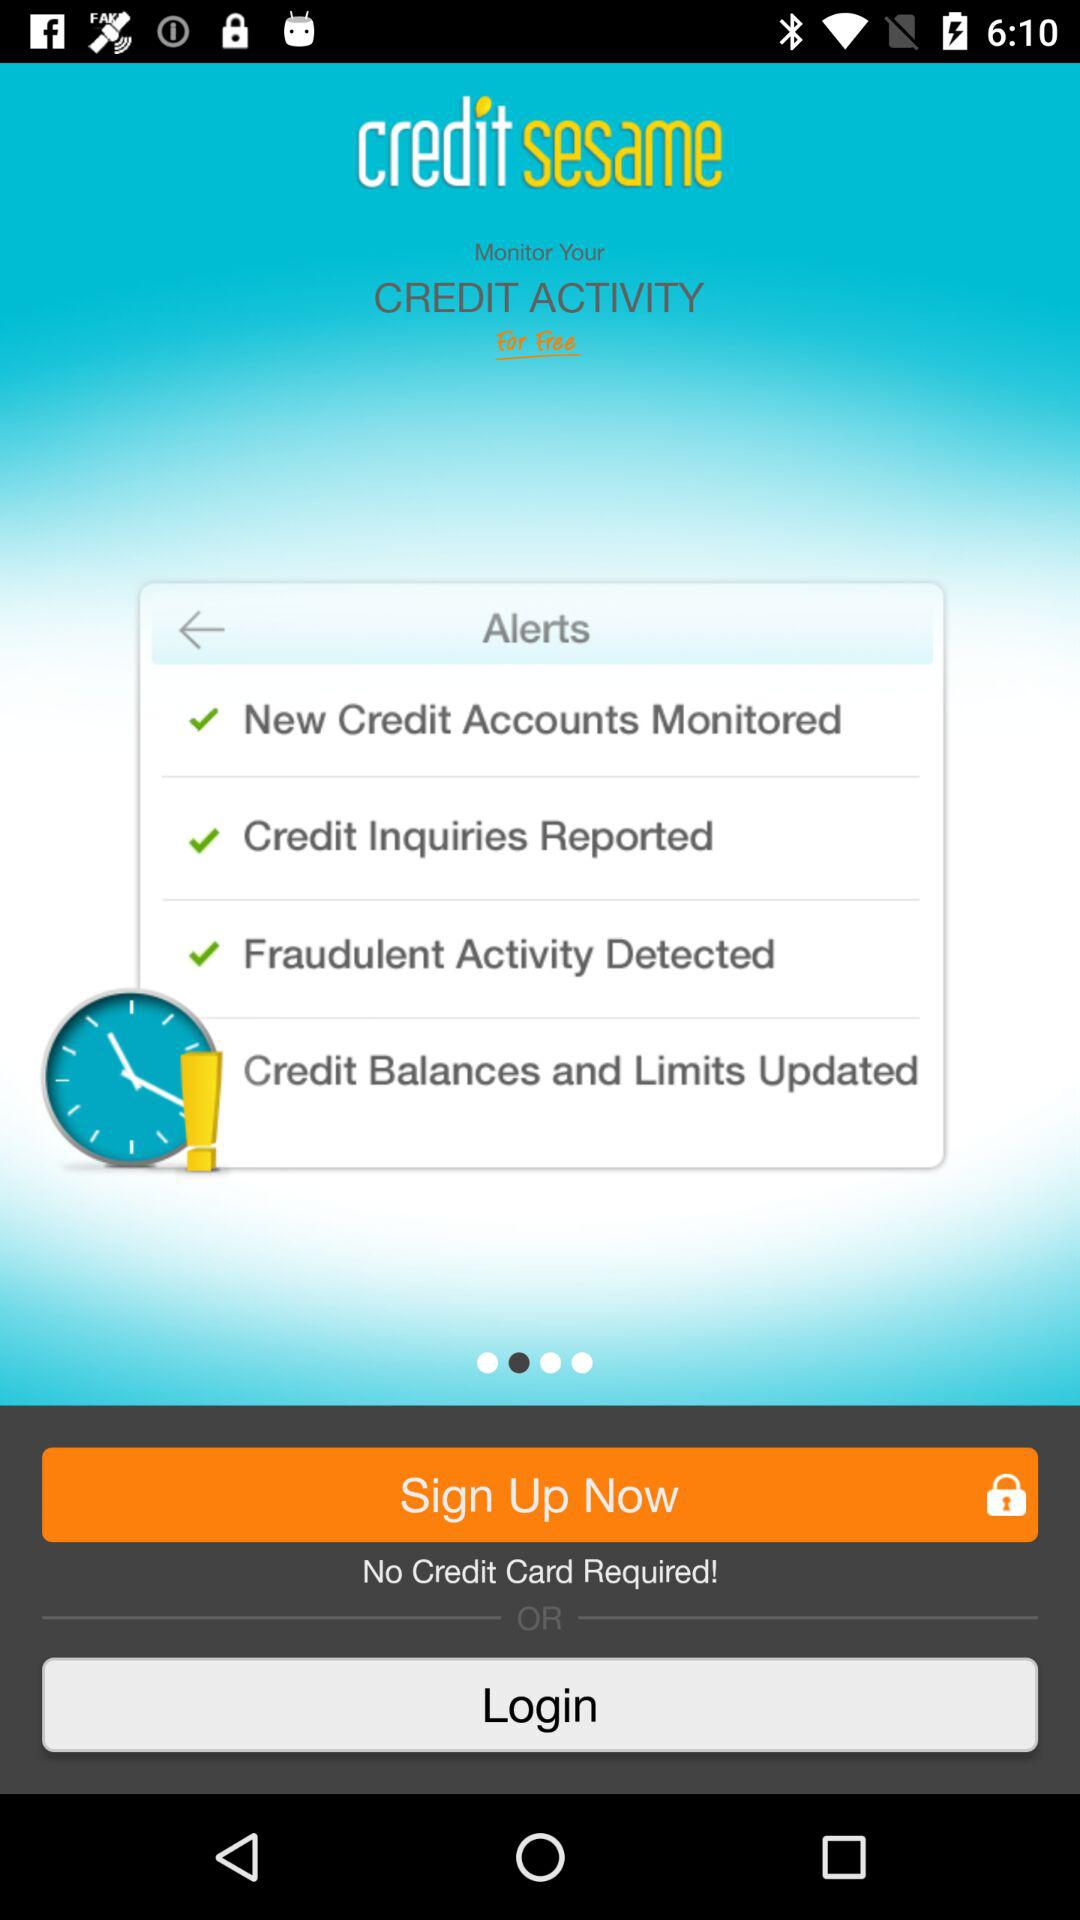What are the different types of alerts? The different types of alerts are "New Credit Accounts Monitored", "Credit Inquiries Reported", "Fraudulent Activity Detected" and "Credit Balances and Limits Updated". 